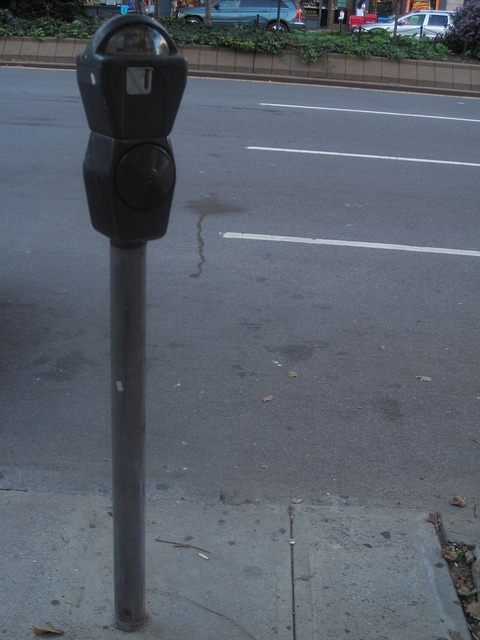Describe the objects in this image and their specific colors. I can see parking meter in black, gray, and darkblue tones, car in black, blue, and gray tones, and car in black, lightblue, darkgray, and gray tones in this image. 